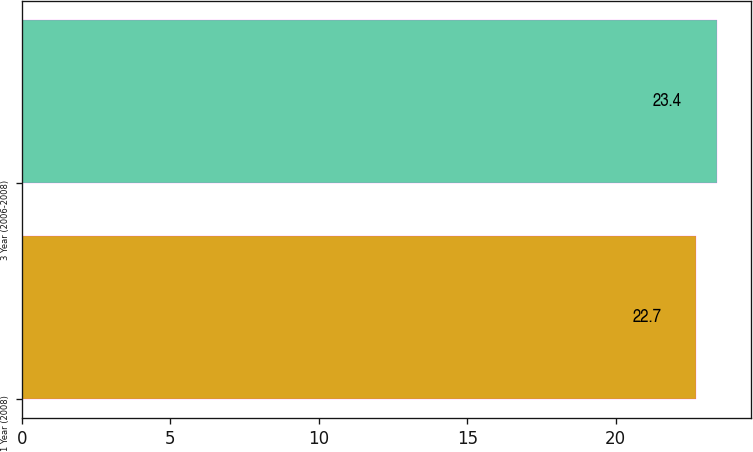Convert chart. <chart><loc_0><loc_0><loc_500><loc_500><bar_chart><fcel>1 Year (2008)<fcel>3 Year (2006-2008)<nl><fcel>22.7<fcel>23.4<nl></chart> 